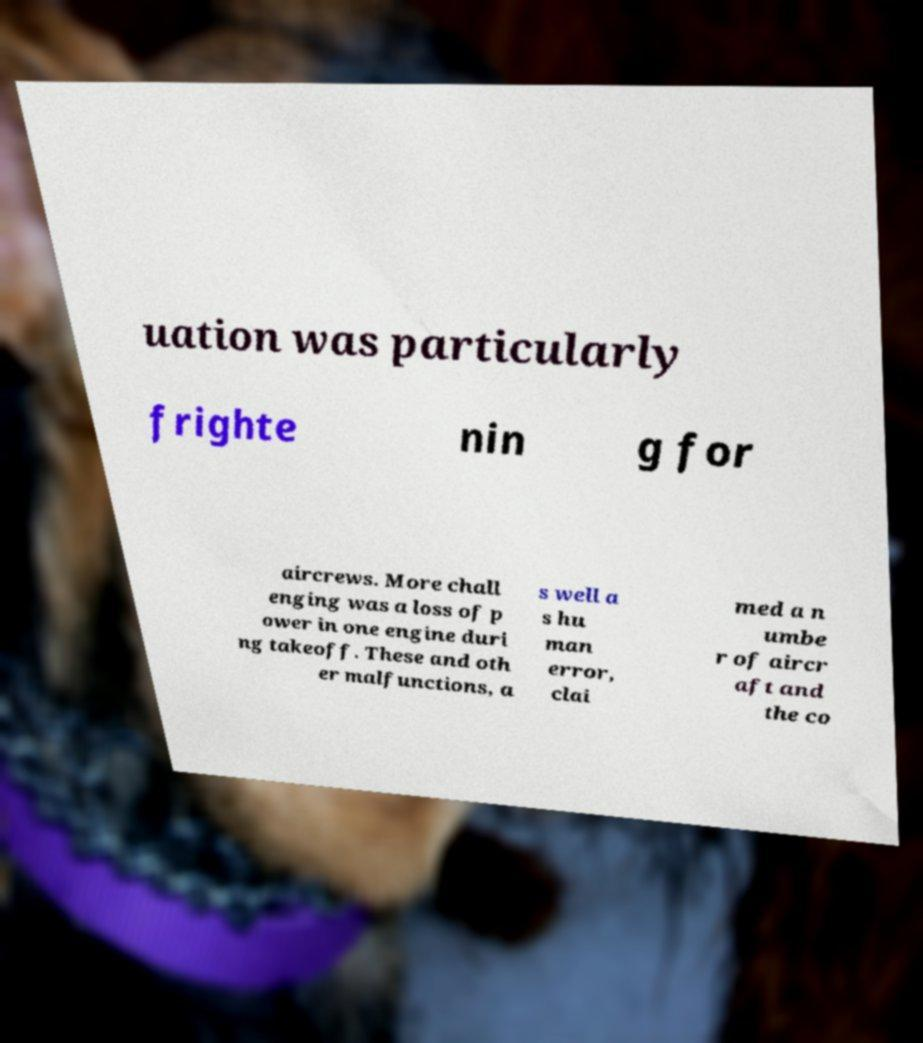Can you read and provide the text displayed in the image?This photo seems to have some interesting text. Can you extract and type it out for me? uation was particularly frighte nin g for aircrews. More chall enging was a loss of p ower in one engine duri ng takeoff. These and oth er malfunctions, a s well a s hu man error, clai med a n umbe r of aircr aft and the co 